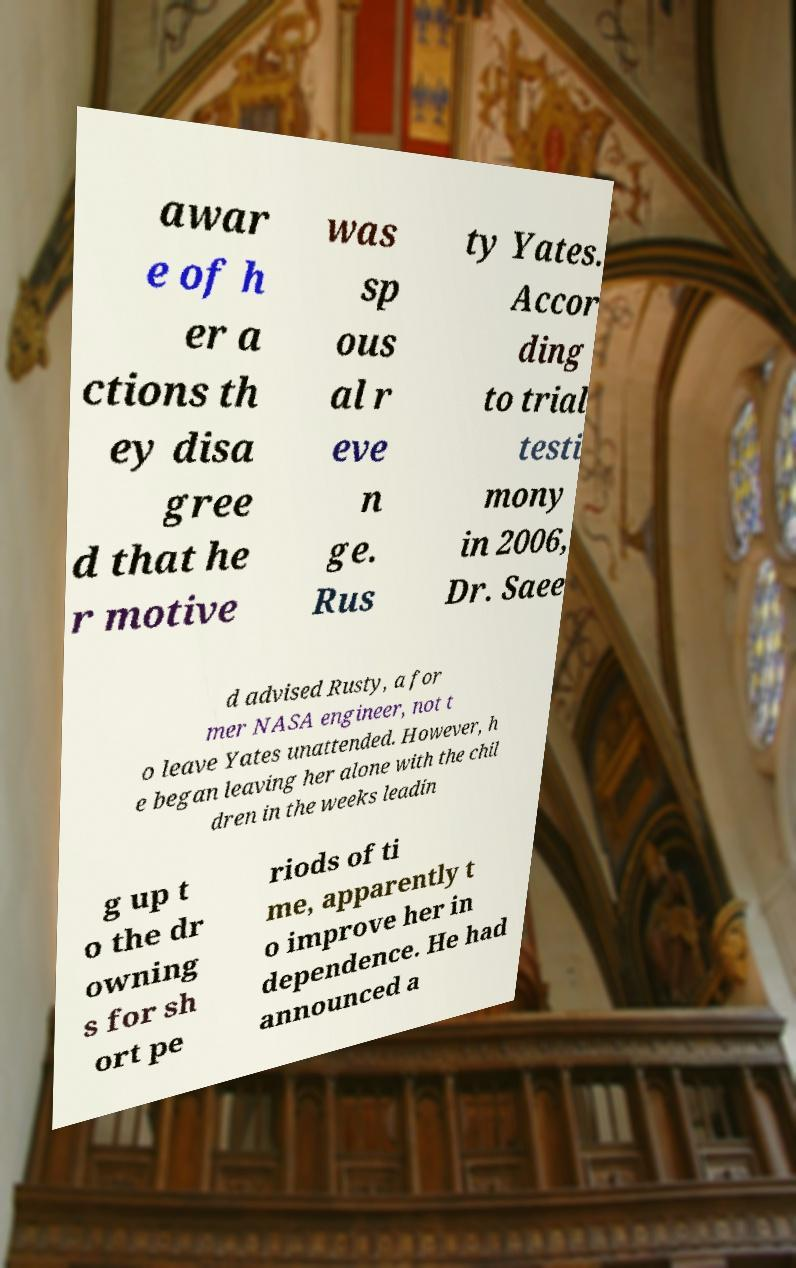I need the written content from this picture converted into text. Can you do that? awar e of h er a ctions th ey disa gree d that he r motive was sp ous al r eve n ge. Rus ty Yates. Accor ding to trial testi mony in 2006, Dr. Saee d advised Rusty, a for mer NASA engineer, not t o leave Yates unattended. However, h e began leaving her alone with the chil dren in the weeks leadin g up t o the dr owning s for sh ort pe riods of ti me, apparently t o improve her in dependence. He had announced a 